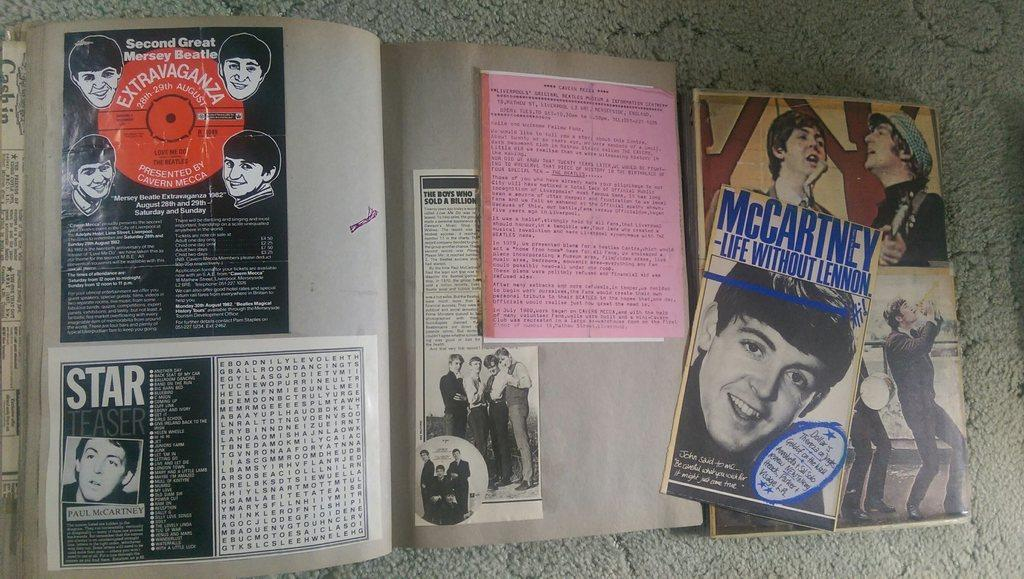<image>
Provide a brief description of the given image. A picture of Paul McCartney has Star written over it. 